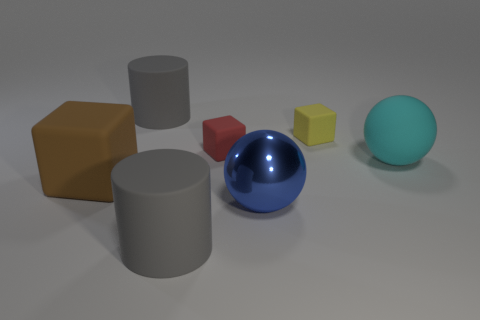Subtract all tiny red matte blocks. How many blocks are left? 2 Add 1 gray cylinders. How many objects exist? 8 Subtract all brown cylinders. Subtract all gray balls. How many cylinders are left? 2 Subtract all brown cubes. How many cubes are left? 2 Subtract all balls. How many objects are left? 5 Subtract 2 cylinders. How many cylinders are left? 0 Subtract all gray balls. How many green cylinders are left? 0 Subtract all green spheres. Subtract all red blocks. How many objects are left? 6 Add 5 large cubes. How many large cubes are left? 6 Add 1 yellow blocks. How many yellow blocks exist? 2 